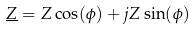<formula> <loc_0><loc_0><loc_500><loc_500>\underline { Z } = Z \cos ( \phi ) + j Z \sin ( \phi )</formula> 